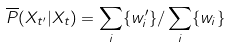Convert formula to latex. <formula><loc_0><loc_0><loc_500><loc_500>\overline { P } ( X _ { t ^ { \prime } } | X _ { t } ) = \sum _ { i } \{ w _ { i } ^ { \prime } \} / \sum _ { i } \{ w _ { i } \}</formula> 